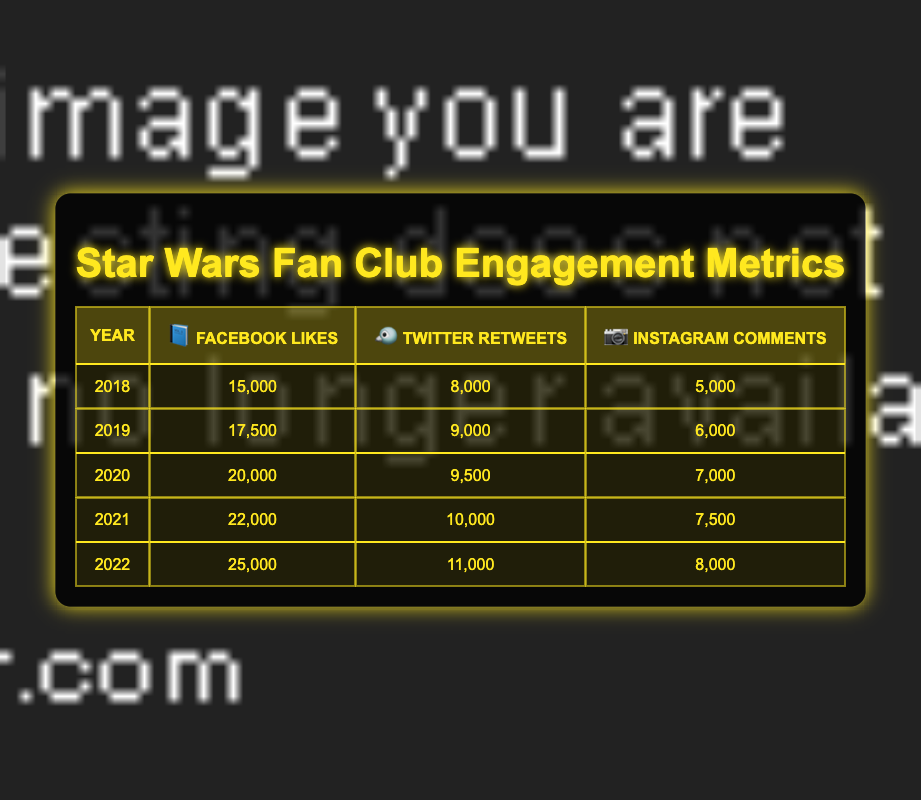What was the total number of Facebook Likes in 2020? The table shows that in 2020, Facebook had 20,000 Likes. This value can be retrieved directly from the corresponding cell under the Facebook Likes column for the year 2020.
Answer: 20,000 What engagement type had the highest count in 2022 across all platforms? In 2022, Facebook Likes had 25,000, Twitter Retweets had 11,000, and Instagram Comments had 8,000. The highest count among these values is 25,000 for Facebook Likes.
Answer: Facebook Likes How many total Comments were there on Instagram from 2018 to 2022? To find the total Comments for Instagram, sum the values for each year: 5,000 (2018) + 6,000 (2019) + 7,000 (2020) + 7,500 (2021) + 8,000 (2022) = 33,500.
Answer: 33,500 Did the number of Retweets on Twitter increase every year from 2018 to 2022? The Retweets for Twitter were 8,000 (2018), 9,000 (2019), 9,500 (2020), 10,000 (2021), and 11,000 (2022). Since all values show an increase from the previous year, the answer is yes.
Answer: Yes What was the average number of Engagements (Likes, Retweets, and Comments) on all platforms for the year 2021? The totals for 2021 are: Facebook Likes = 22,000, Twitter Retweets = 10,000, and Instagram Comments = 7,500. Sum these values: 22,000 + 10,000 + 7,500 = 39,500. There are 3 engagement types, so the average is 39,500 / 3 = 13,166.67.
Answer: 13,166.67 